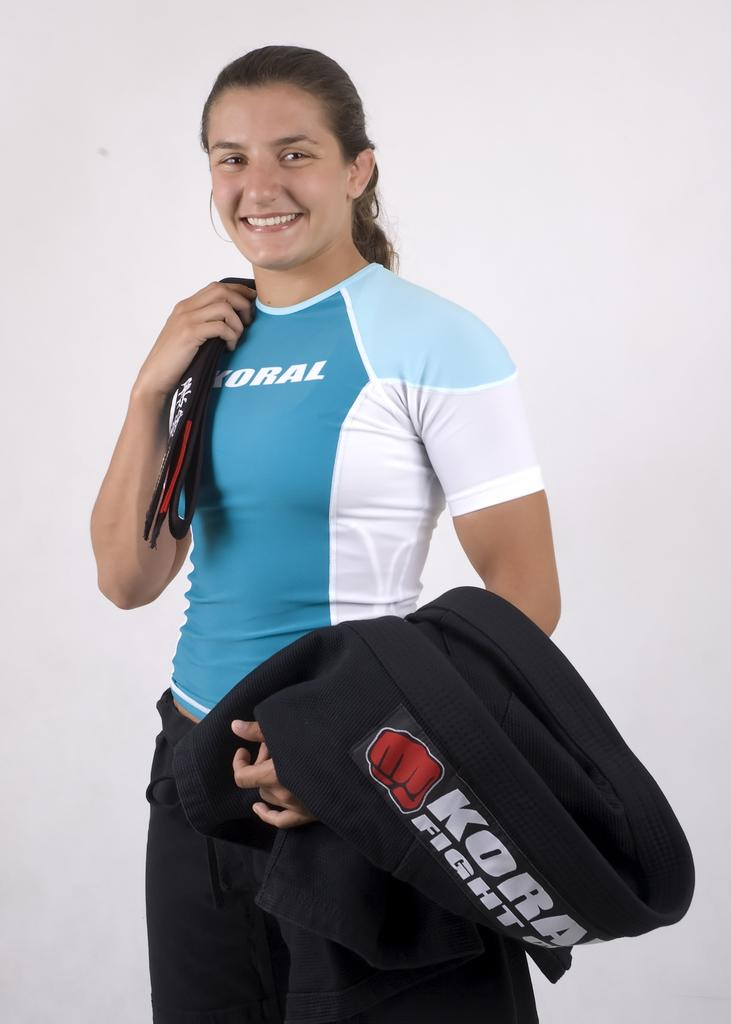<image>
Relay a brief, clear account of the picture shown. The sports girls shown is wearing a koral top. 